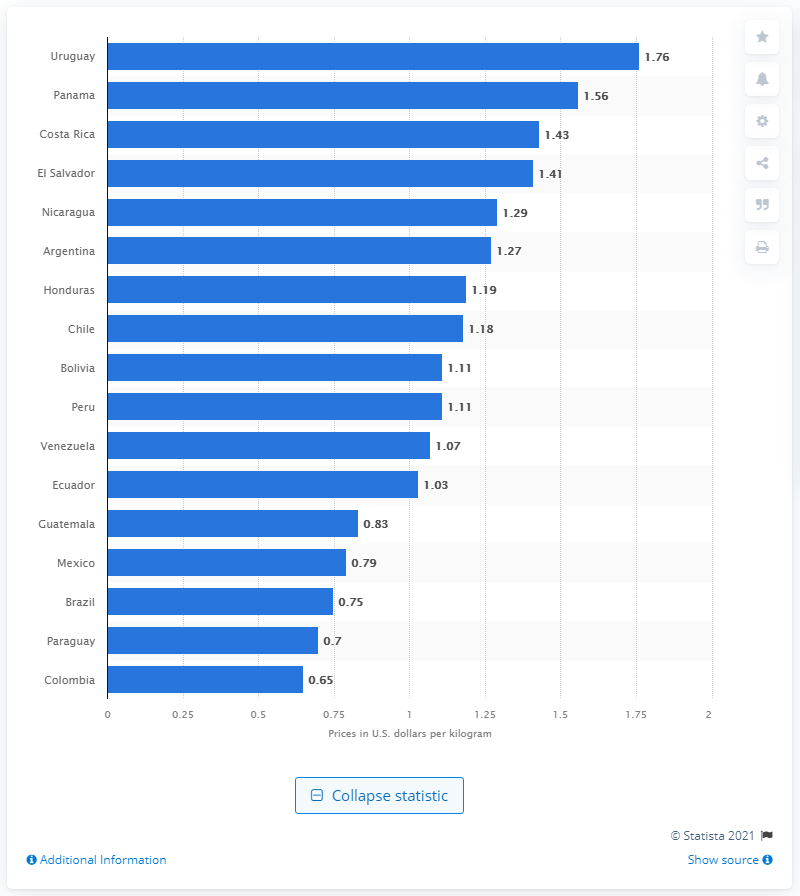Draw attention to some important aspects in this diagram. Uruguay's average price per kilogram of bananas in May of 2020 was 1.76. 